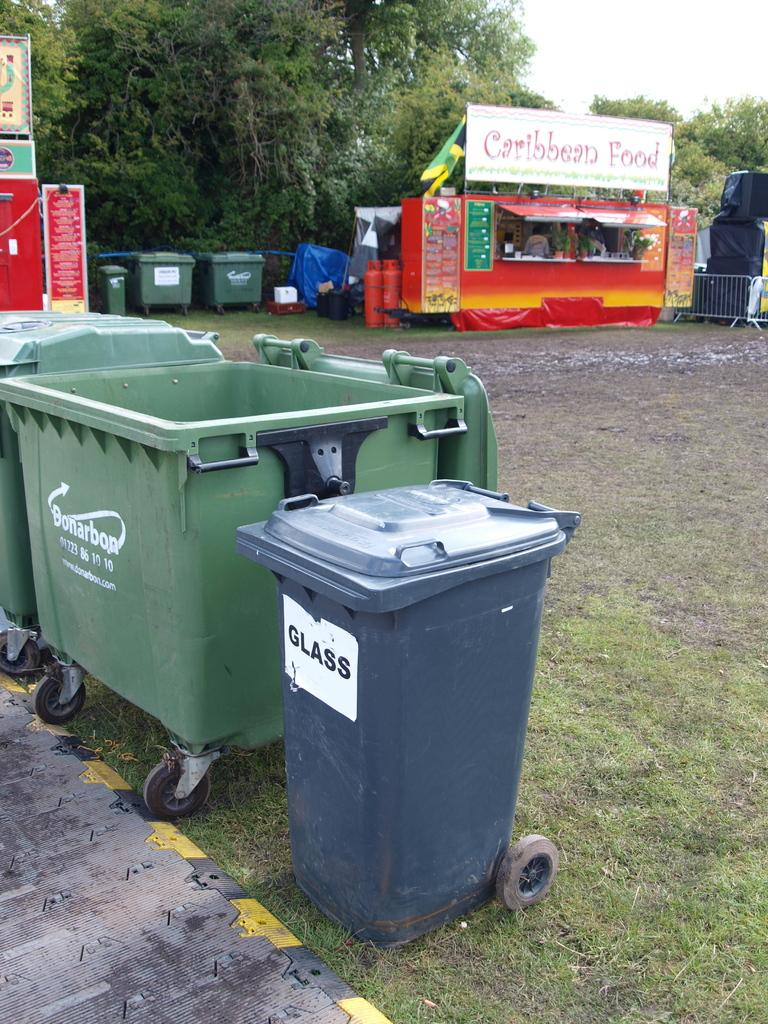<image>
Create a compact narrative representing the image presented. A stand for Caribbean Food is brightly colored with red and orange 